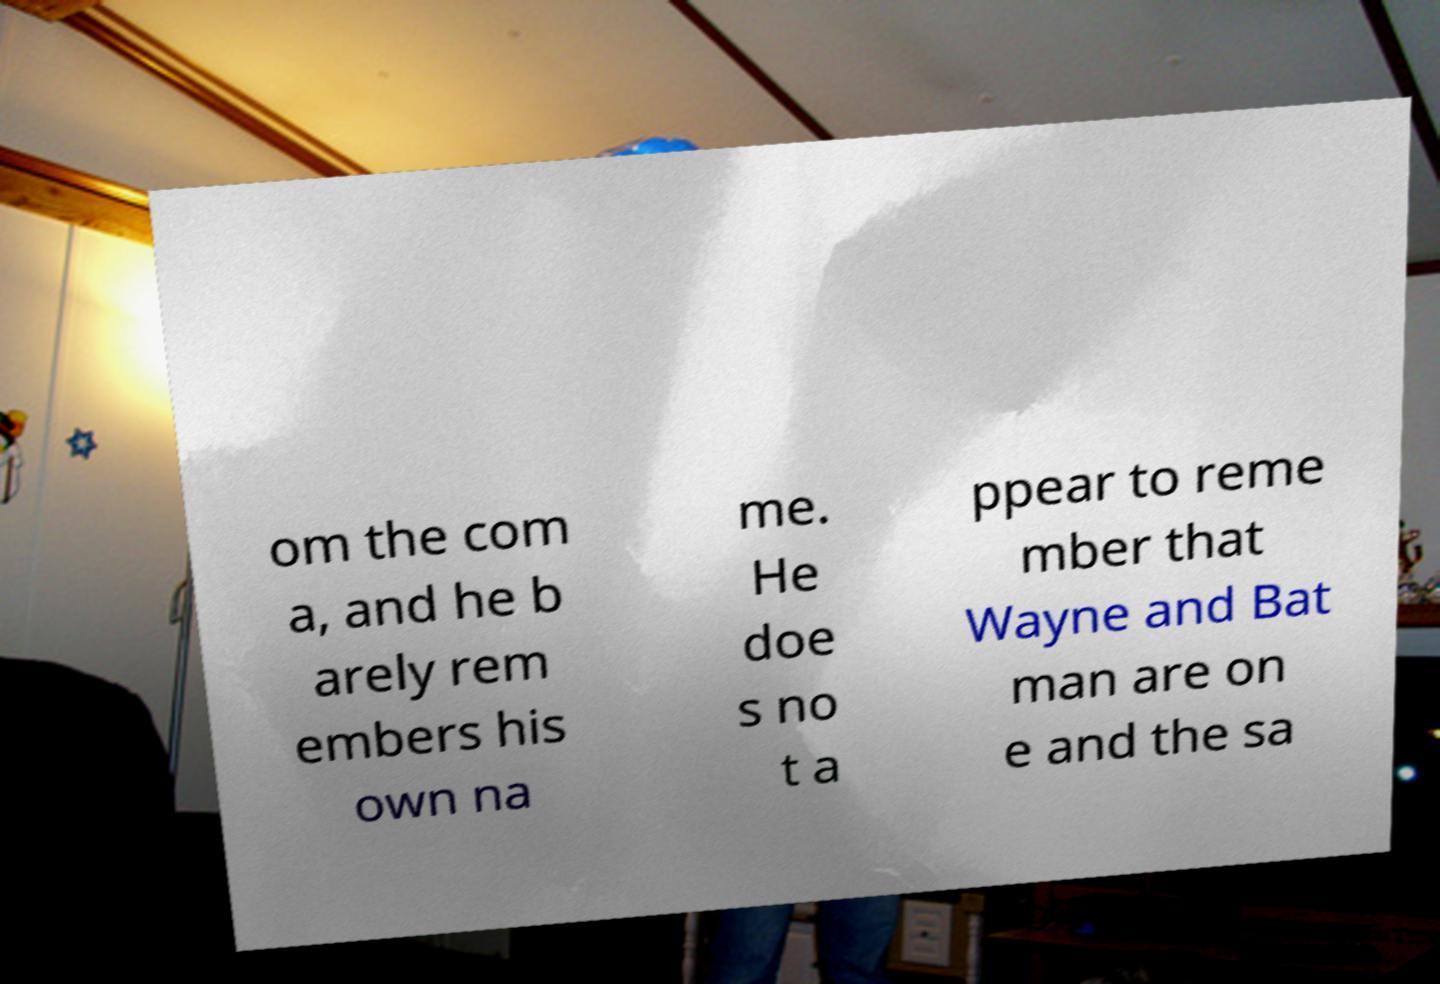For documentation purposes, I need the text within this image transcribed. Could you provide that? om the com a, and he b arely rem embers his own na me. He doe s no t a ppear to reme mber that Wayne and Bat man are on e and the sa 